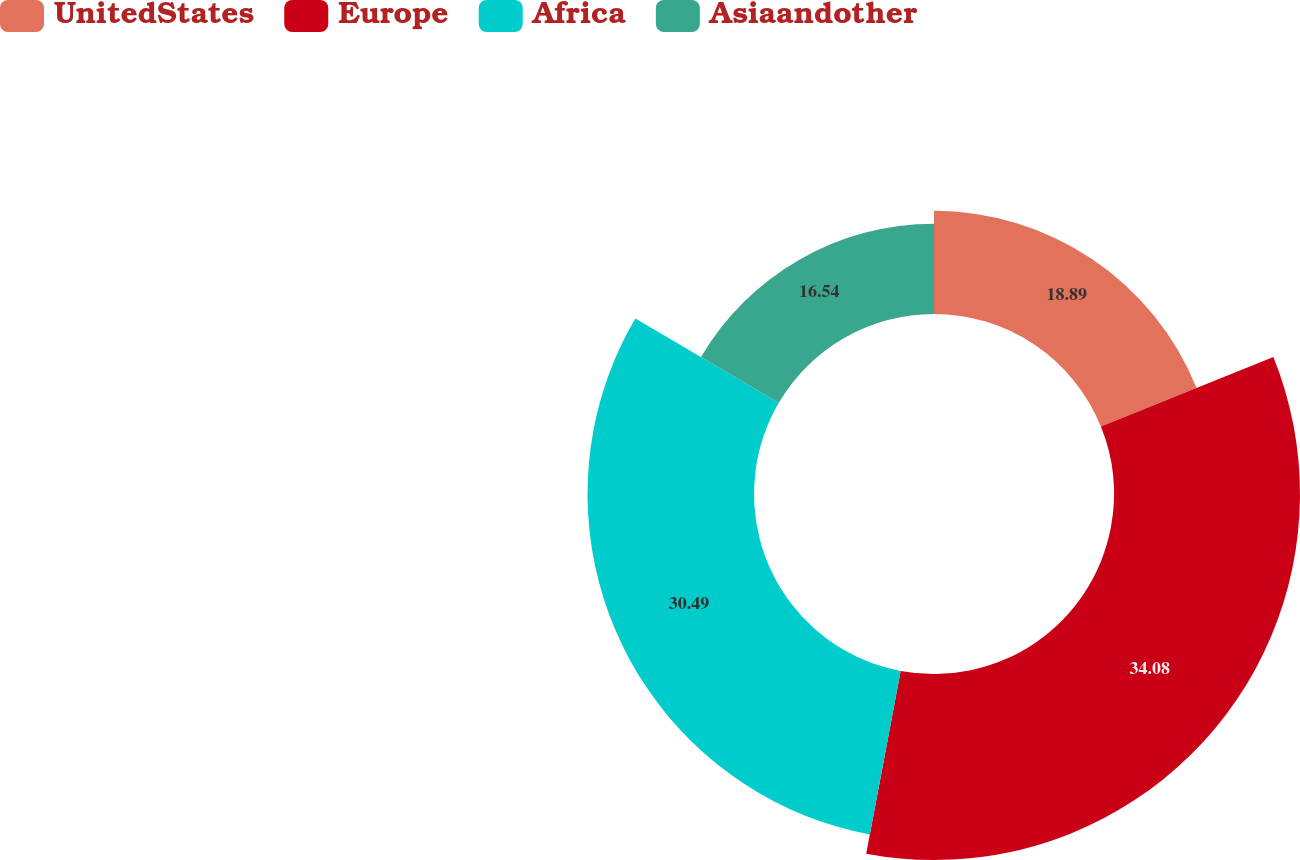<chart> <loc_0><loc_0><loc_500><loc_500><pie_chart><fcel>UnitedStates<fcel>Europe<fcel>Africa<fcel>Asiaandother<nl><fcel>18.89%<fcel>34.07%<fcel>30.49%<fcel>16.54%<nl></chart> 